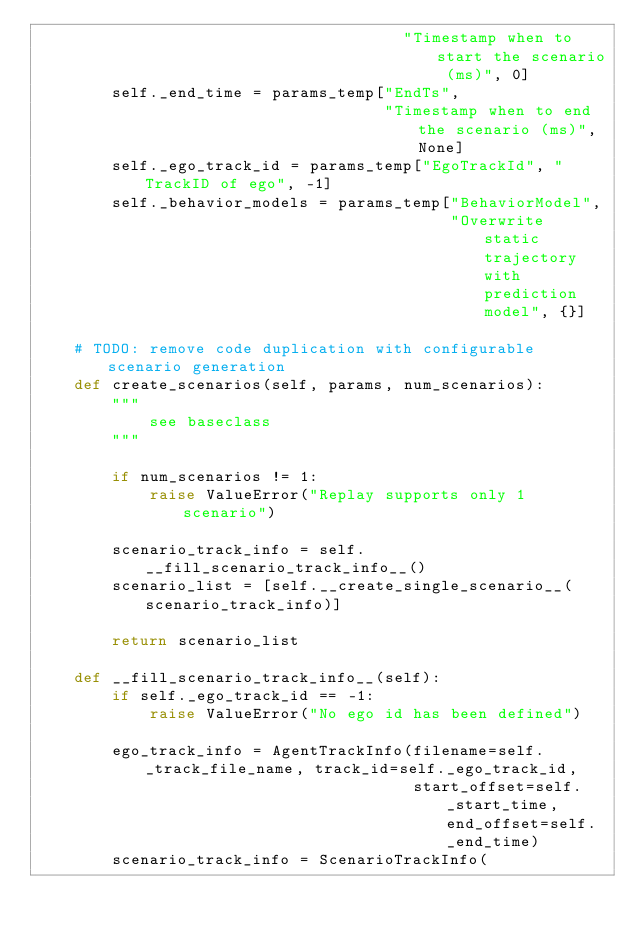Convert code to text. <code><loc_0><loc_0><loc_500><loc_500><_Python_>                                       "Timestamp when to start the scenario (ms)", 0]
        self._end_time = params_temp["EndTs",
                                     "Timestamp when to end the scenario (ms)", None]
        self._ego_track_id = params_temp["EgoTrackId", "TrackID of ego", -1]
        self._behavior_models = params_temp["BehaviorModel",
                                            "Overwrite static trajectory with prediction model", {}]

    # TODO: remove code duplication with configurable scenario generation
    def create_scenarios(self, params, num_scenarios):
        """ 
            see baseclass
        """

        if num_scenarios != 1:
            raise ValueError("Replay supports only 1 scenario")

        scenario_track_info = self.__fill_scenario_track_info__()
        scenario_list = [self.__create_single_scenario__(scenario_track_info)]

        return scenario_list

    def __fill_scenario_track_info__(self):
        if self._ego_track_id == -1:
            raise ValueError("No ego id has been defined")

        ego_track_info = AgentTrackInfo(filename=self._track_file_name, track_id=self._ego_track_id,
                                        start_offset=self._start_time, end_offset=self._end_time)
        scenario_track_info = ScenarioTrackInfo(</code> 